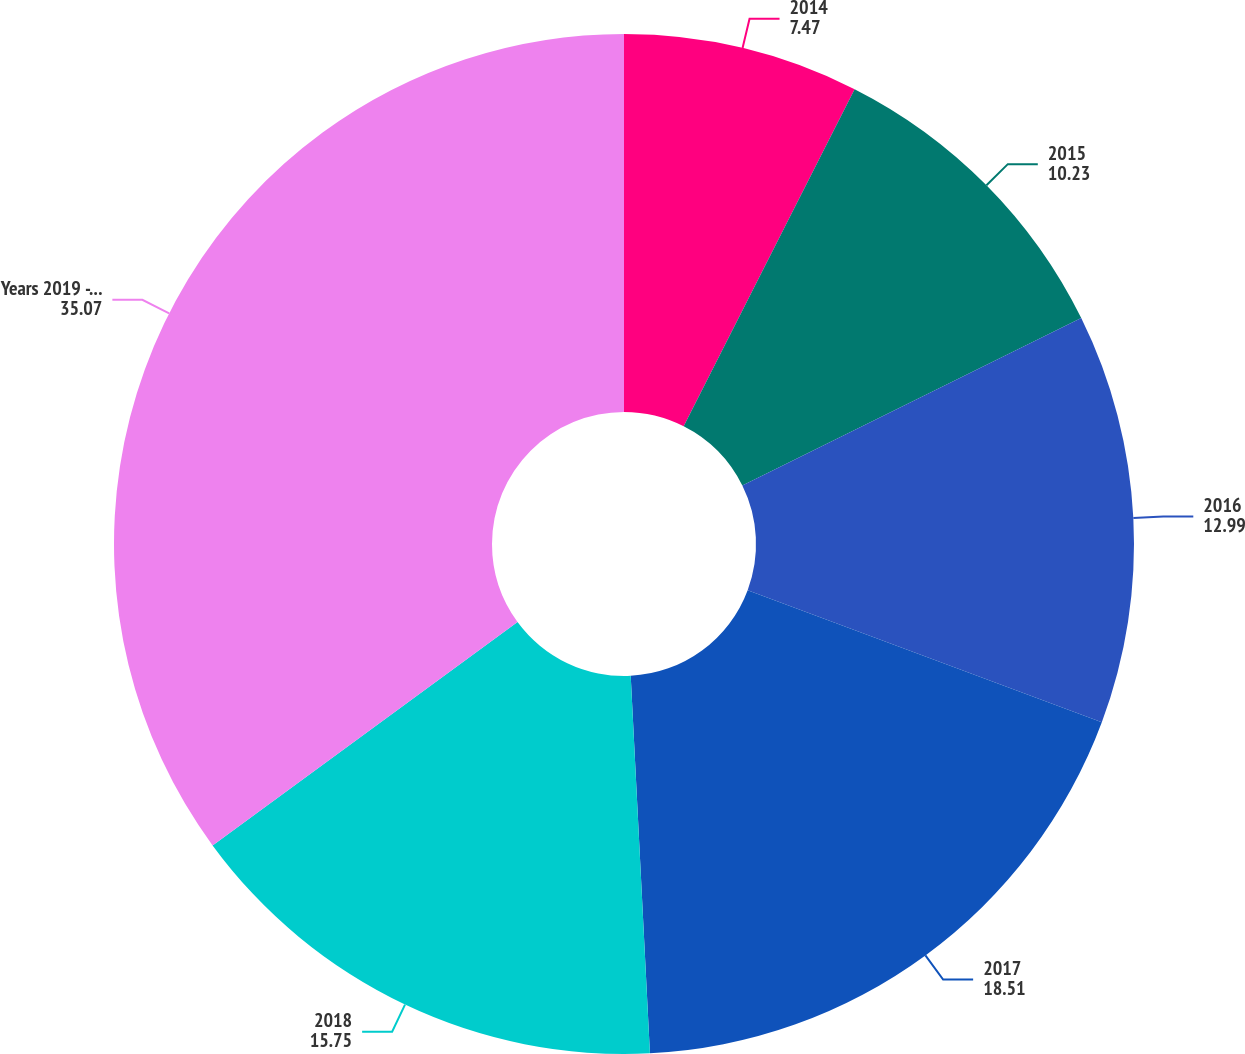Convert chart to OTSL. <chart><loc_0><loc_0><loc_500><loc_500><pie_chart><fcel>2014<fcel>2015<fcel>2016<fcel>2017<fcel>2018<fcel>Years 2019 - 2023<nl><fcel>7.47%<fcel>10.23%<fcel>12.99%<fcel>18.51%<fcel>15.75%<fcel>35.07%<nl></chart> 